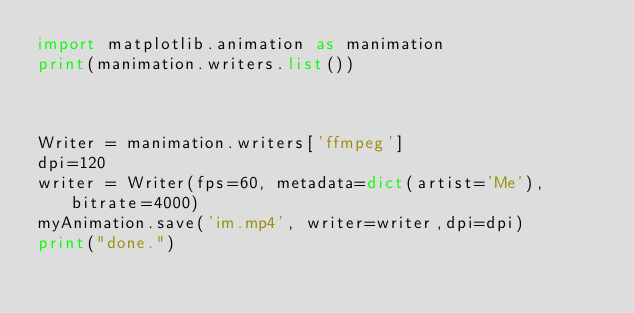Convert code to text. <code><loc_0><loc_0><loc_500><loc_500><_Python_>import matplotlib.animation as manimation
print(manimation.writers.list())



Writer = manimation.writers['ffmpeg']
dpi=120
writer = Writer(fps=60, metadata=dict(artist='Me'), bitrate=4000)
myAnimation.save('im.mp4', writer=writer,dpi=dpi)
print("done.")</code> 